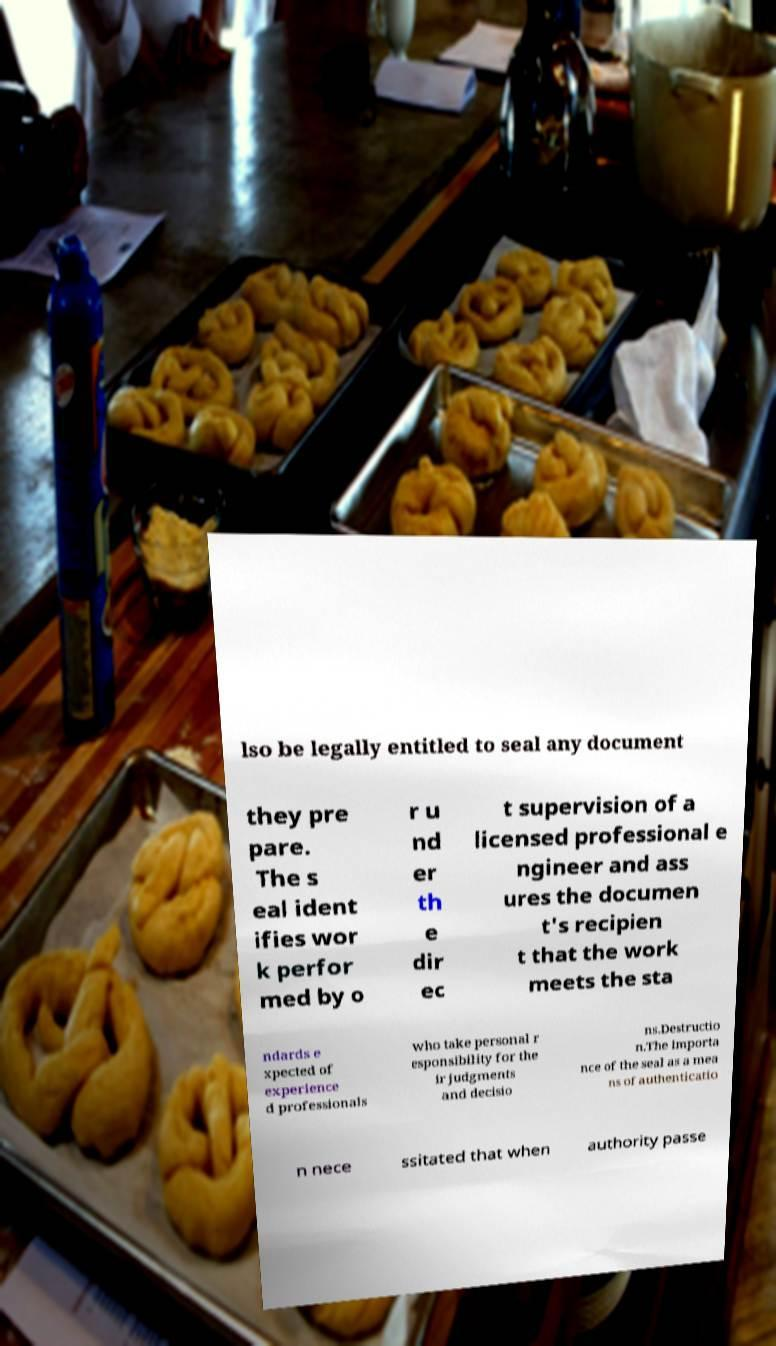For documentation purposes, I need the text within this image transcribed. Could you provide that? lso be legally entitled to seal any document they pre pare. The s eal ident ifies wor k perfor med by o r u nd er th e dir ec t supervision of a licensed professional e ngineer and ass ures the documen t's recipien t that the work meets the sta ndards e xpected of experience d professionals who take personal r esponsibility for the ir judgments and decisio ns.Destructio n.The importa nce of the seal as a mea ns of authenticatio n nece ssitated that when authority passe 